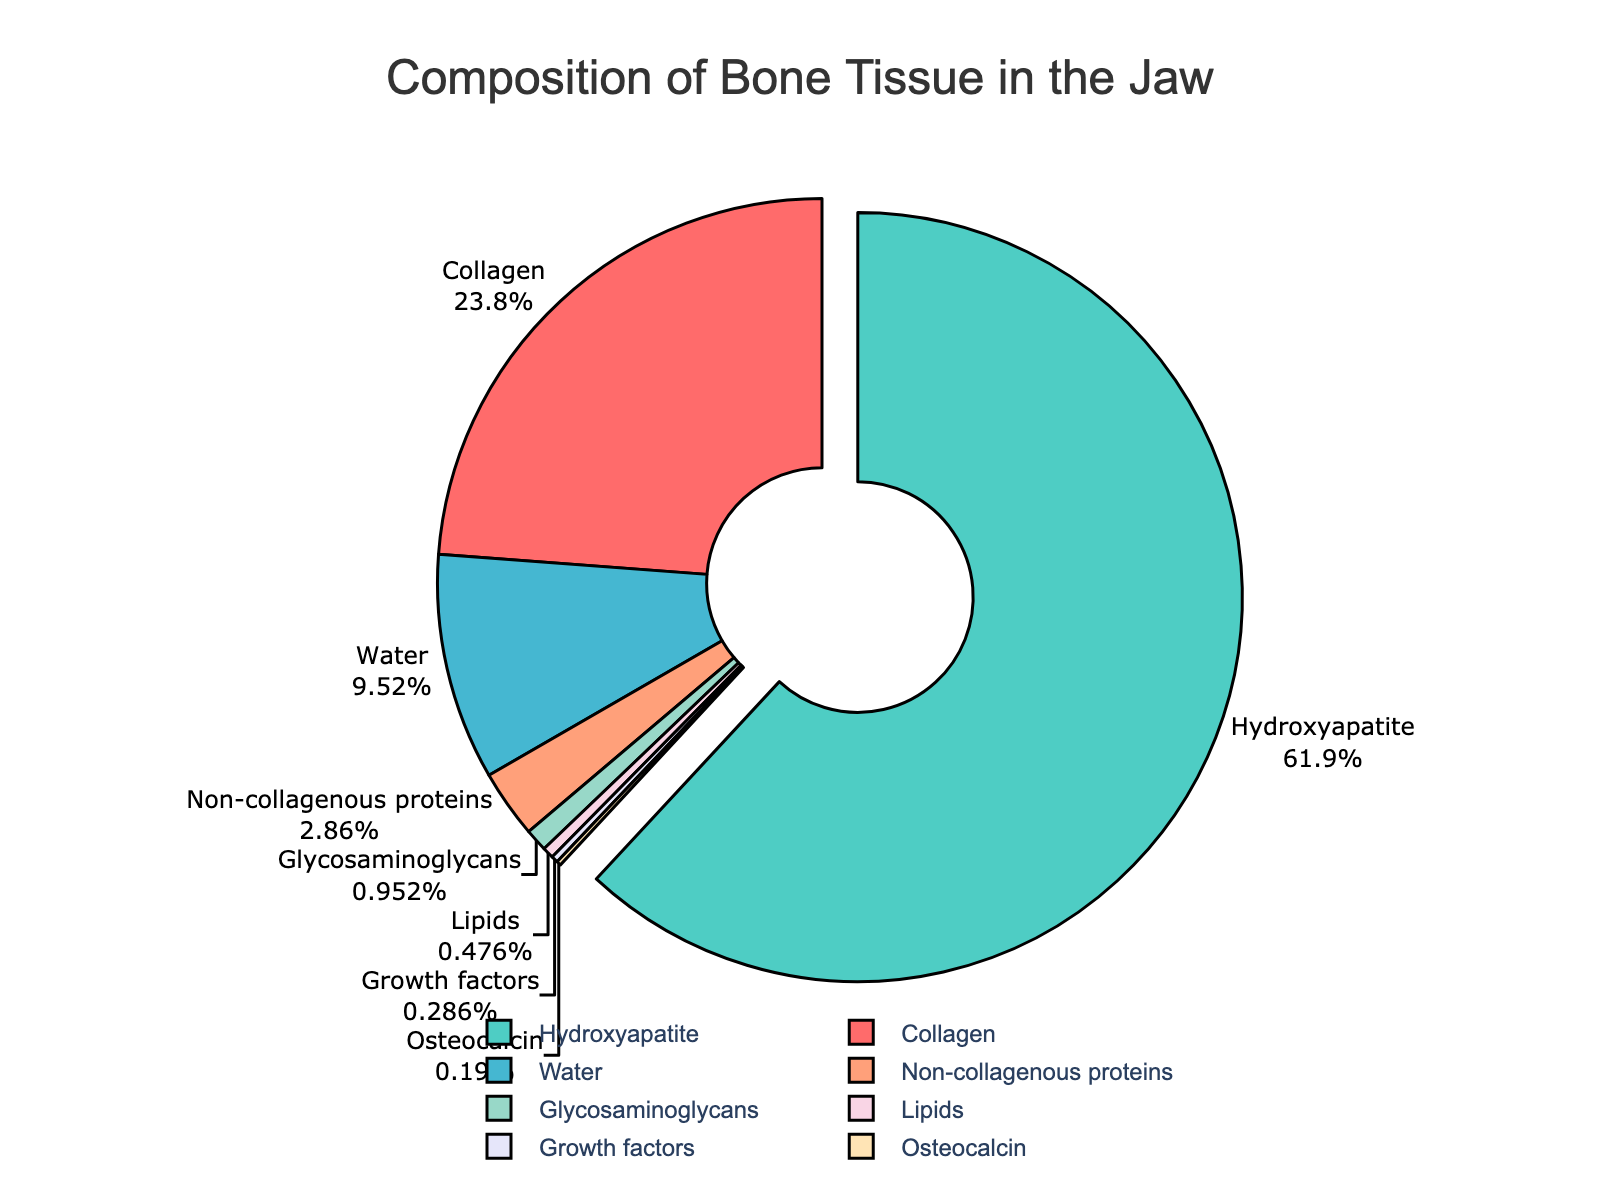What component has the highest percentage in the bone tissue of the jaw? The pie chart shows the composition percentages of different components. Hydroxyapatite is visually shown to take up the largest section of the pie.
Answer: Hydroxyapatite What is the combined percentage of Collagen and Water in the bone tissue of the jaw? From the pie chart, we see that Collagen accounts for 25% and Water for 10%. Adding 25% and 10% gives us 35%.
Answer: 35% Which component's percentage is closest to 2%? Among the components listed, Growth factors (0.3%) and Osteocalcin (0.2%) are the closest to 2%, but Non-collagenous proteins at 3% is the next closest.
Answer: Non-collagenous proteins Order the components by their percentage in descending order. From the pie chart, the descending order in terms of percentage is Hydroxyapatite > Collagen > Water > Non-collagenous proteins > Glycosaminoglycans > Lipids > Growth factors > Osteocalcin.
Answer: Hydroxyapatite, Collagen, Water, Non-collagenous proteins, Glycosaminoglycans, Lipids, Growth factors, Osteocalcin Which component is visually represented with the color red? Based on the legend or the use of colors in the pie sections, Collagen is represented with the red color.
Answer: Collagen How much larger is the percentage of Hydroxyapatite compared to Water? Hydroxyapatite is 65% and Water is 10%. Subtracting 10% from 65% gives us 55%.
Answer: 55% Which two components have the lowest percentage in bone tissue composition? By examining the smallest portions of the pie chart, we find that Growth factors (0.3%) and Osteocalcin (0.2%) have the lowest percentages.
Answer: Growth factors and Osteocalcin What is the total percentage of components that make up less than 1%? Glycosaminoglycans (1%), Lipids (0.5%), Growth factors (0.3%), and Osteocalcin (0.2%) sum up to 2%.
Answer: 2% Are there more components with a percentage higher than 20% or less than 5%? From the pie chart, Hydroxyapatite (65%) and Collagen (25%) are higher than 20%, making 2 components. Non-collagenous proteins (3%), Glycosaminoglycans (1%), Lipids (0.5%), Growth factors (0.3%), and Osteocalcin (0.2%) are less than 5%, making 5 components.
Answer: Less than 5% If the percentage of Hydroxyapatite were doubled, what would the total percentage become compared to 100%? Doubling Hydroxyapatite gives us 65% * 2 = 130%. Adding this to the remaining components (35%) results in 165%, which is 65% more than 100%.
Answer: 65% more 